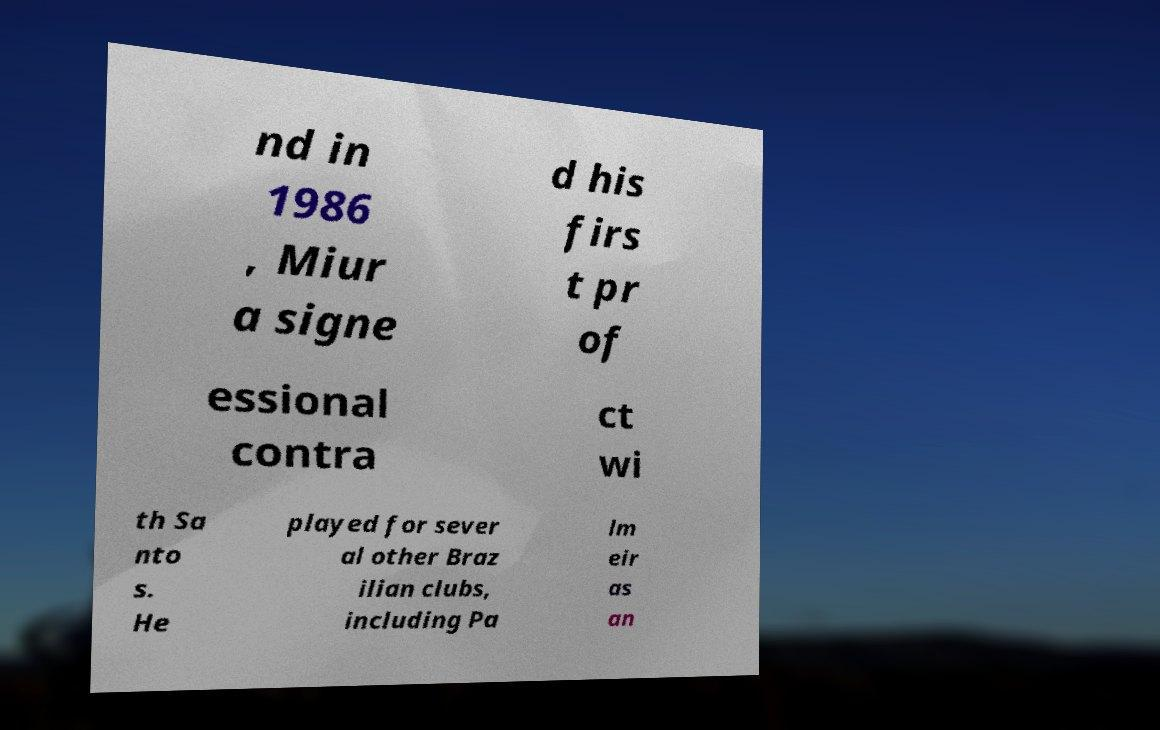Please read and relay the text visible in this image. What does it say? nd in 1986 , Miur a signe d his firs t pr of essional contra ct wi th Sa nto s. He played for sever al other Braz ilian clubs, including Pa lm eir as an 